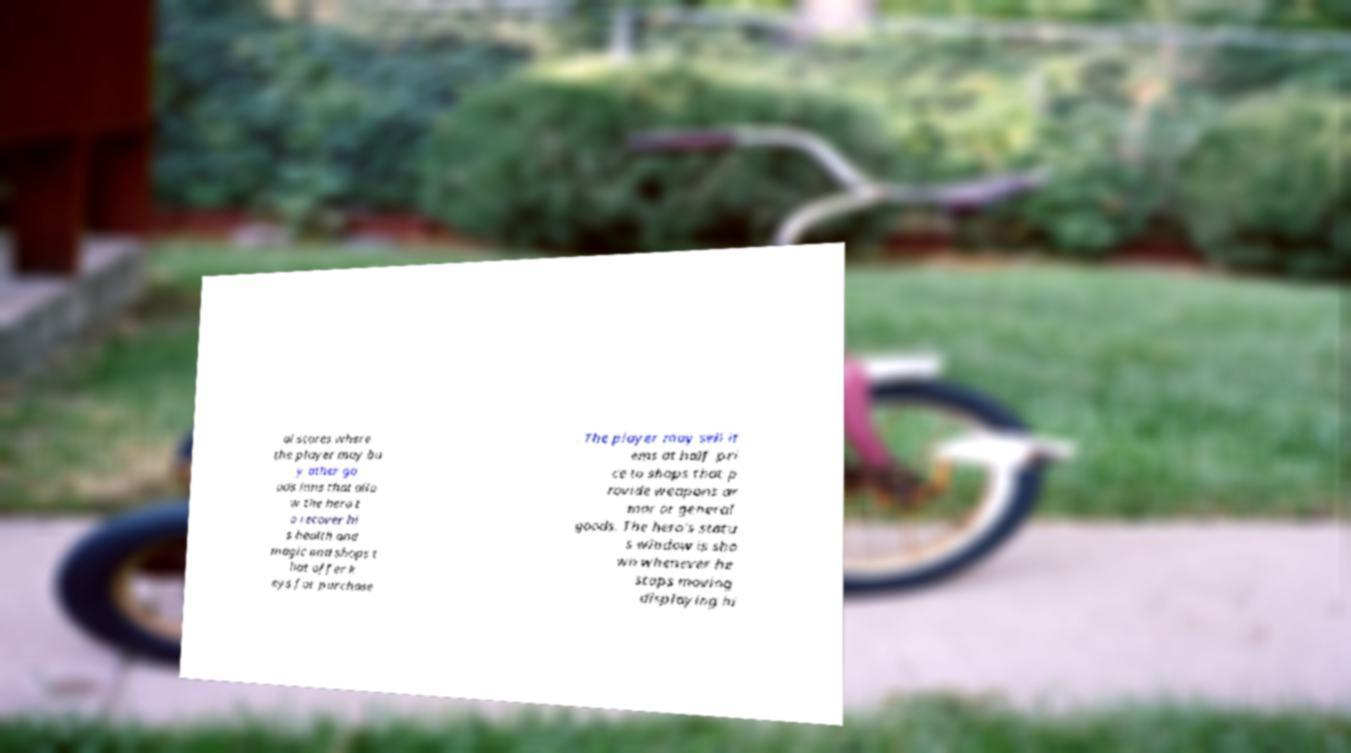There's text embedded in this image that I need extracted. Can you transcribe it verbatim? al stores where the player may bu y other go ods inns that allo w the hero t o recover hi s health and magic and shops t hat offer k eys for purchase . The player may sell it ems at half pri ce to shops that p rovide weapons ar mor or general goods. The hero's statu s window is sho wn whenever he stops moving displaying hi 